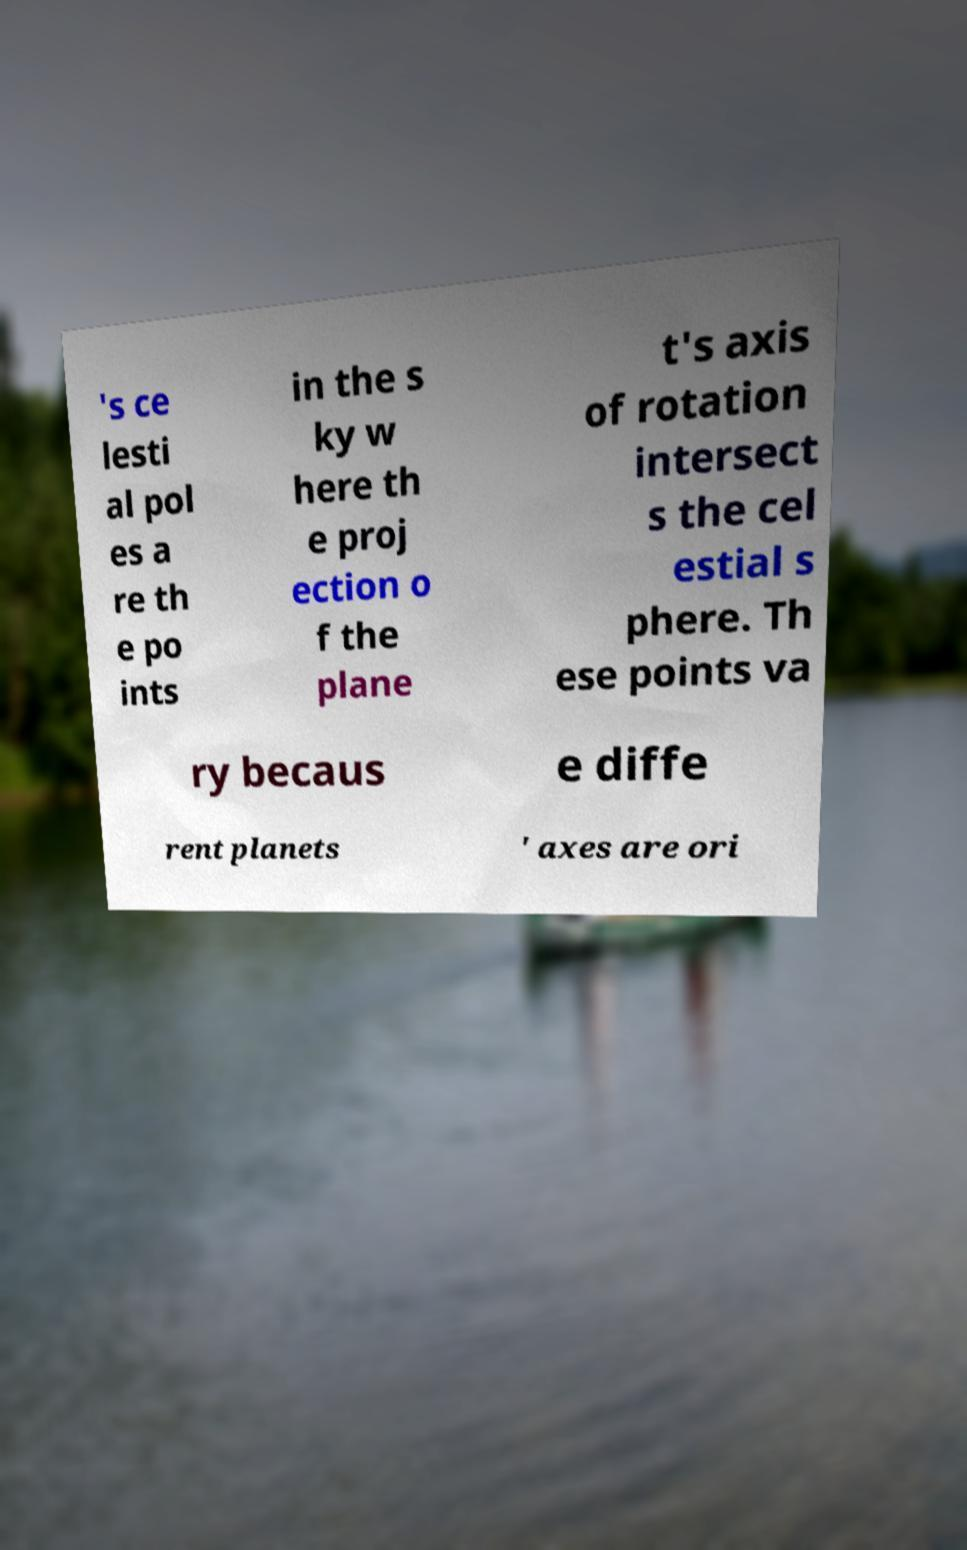Please identify and transcribe the text found in this image. 's ce lesti al pol es a re th e po ints in the s ky w here th e proj ection o f the plane t's axis of rotation intersect s the cel estial s phere. Th ese points va ry becaus e diffe rent planets ' axes are ori 